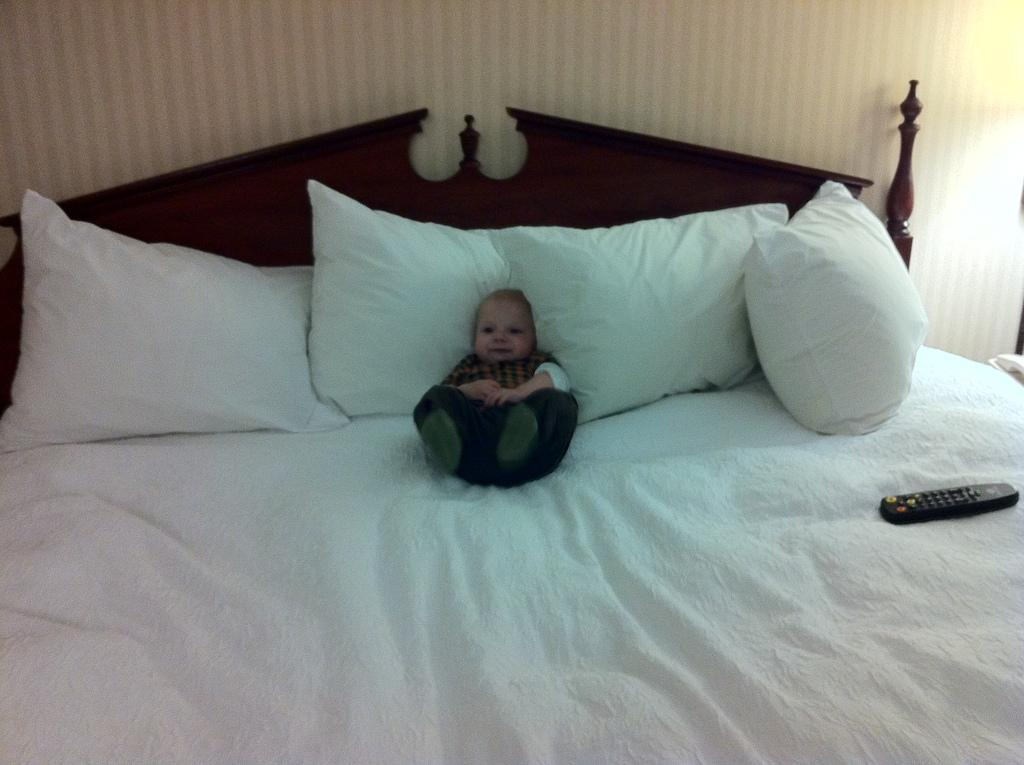What is the kid doing in the image? The kid is laying on the bed. What can be found on the bed besides the kid? There are pillows on the bed. What object is visible that might be used for controlling electronic devices? There is a remote control visible. What can be seen in the background of the image? There is a wall in the background of the image. How many houses can be seen in the image? There are no houses visible in the image. What type of sand can be seen on the bed? There is no sand present in the image; it features a kid laying on a bed with pillows. 